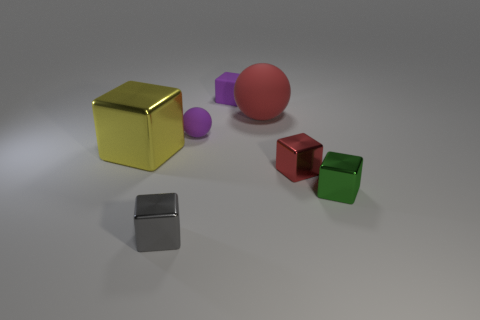Subtract all gray blocks. How many blocks are left? 4 Subtract all gray cubes. How many cubes are left? 4 Add 2 gray things. How many objects exist? 9 Subtract all spheres. How many objects are left? 5 Subtract 3 blocks. How many blocks are left? 2 Add 4 big green things. How many big green things exist? 4 Subtract 0 cyan spheres. How many objects are left? 7 Subtract all purple blocks. Subtract all yellow cylinders. How many blocks are left? 4 Subtract all tiny blue shiny spheres. Subtract all large yellow blocks. How many objects are left? 6 Add 1 small gray objects. How many small gray objects are left? 2 